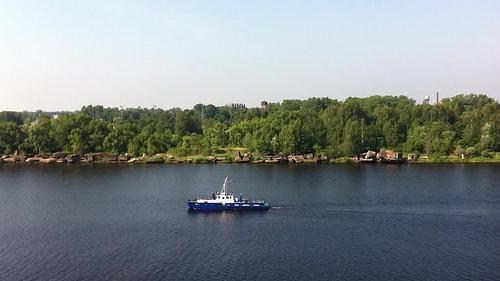How many boats are there?
Give a very brief answer. 1. 